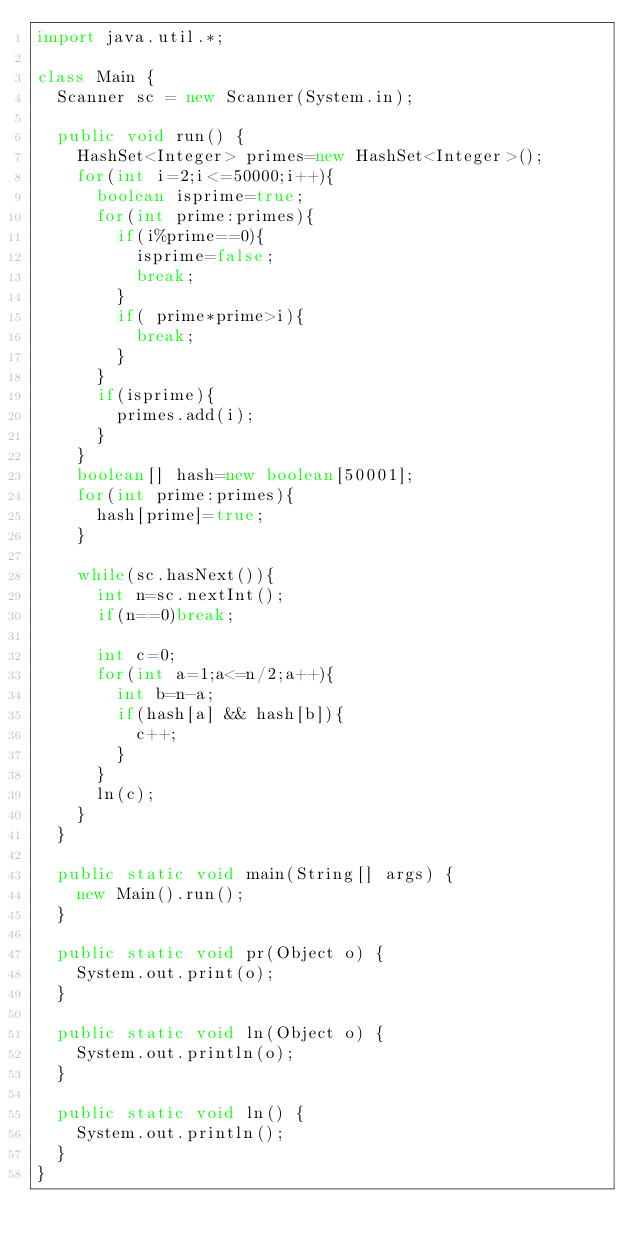Convert code to text. <code><loc_0><loc_0><loc_500><loc_500><_Java_>import java.util.*;

class Main {
	Scanner sc = new Scanner(System.in);

	public void run() {
		HashSet<Integer> primes=new HashSet<Integer>();
		for(int i=2;i<=50000;i++){
			boolean isprime=true;
			for(int prime:primes){
				if(i%prime==0){
					isprime=false;
					break;
				}
				if( prime*prime>i){
					break;
				}
			}
			if(isprime){
				primes.add(i);
			}
		}
		boolean[] hash=new boolean[50001];
		for(int prime:primes){
			hash[prime]=true;
		}

		while(sc.hasNext()){
			int n=sc.nextInt();
			if(n==0)break;

			int c=0;
			for(int a=1;a<=n/2;a++){
				int b=n-a;
				if(hash[a] && hash[b]){
					c++;
				}
			}
			ln(c);
		}
	}

	public static void main(String[] args) {
		new Main().run();
	}

	public static void pr(Object o) {
		System.out.print(o);
	}

	public static void ln(Object o) {
		System.out.println(o);
	}

	public static void ln() {
		System.out.println();
	}
}</code> 